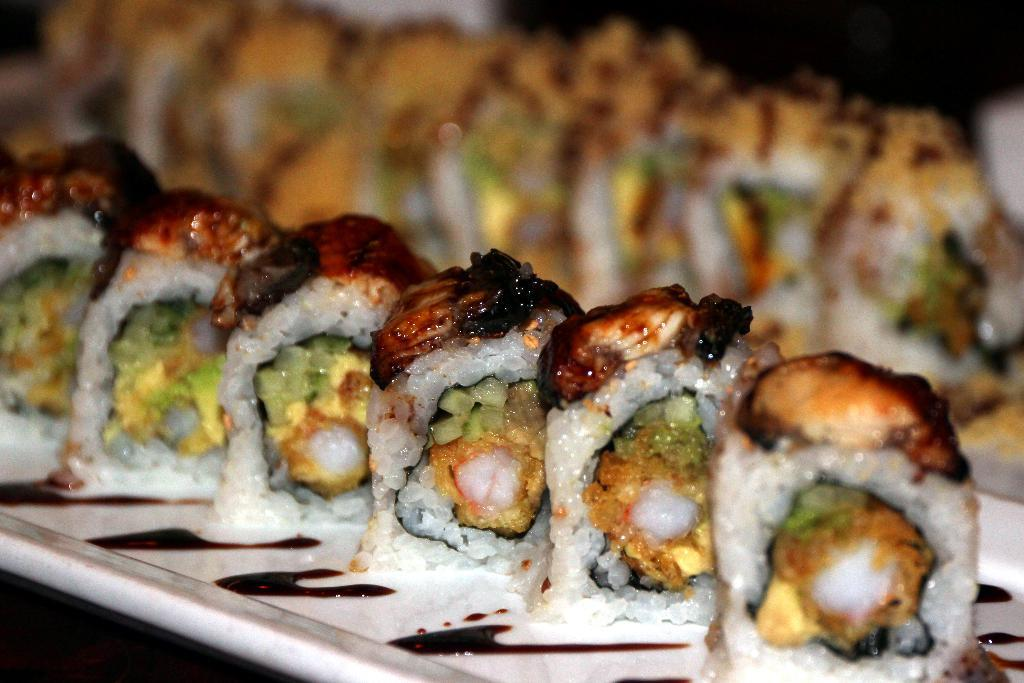What is located in the center of the image? There is a table in the center of the image. What is placed on the table? There is a plate on the table. What can be found on the plate? There are food items on the plate. What type of powder can be seen covering the food items on the plate? There is no powder visible on the food items in the image. 